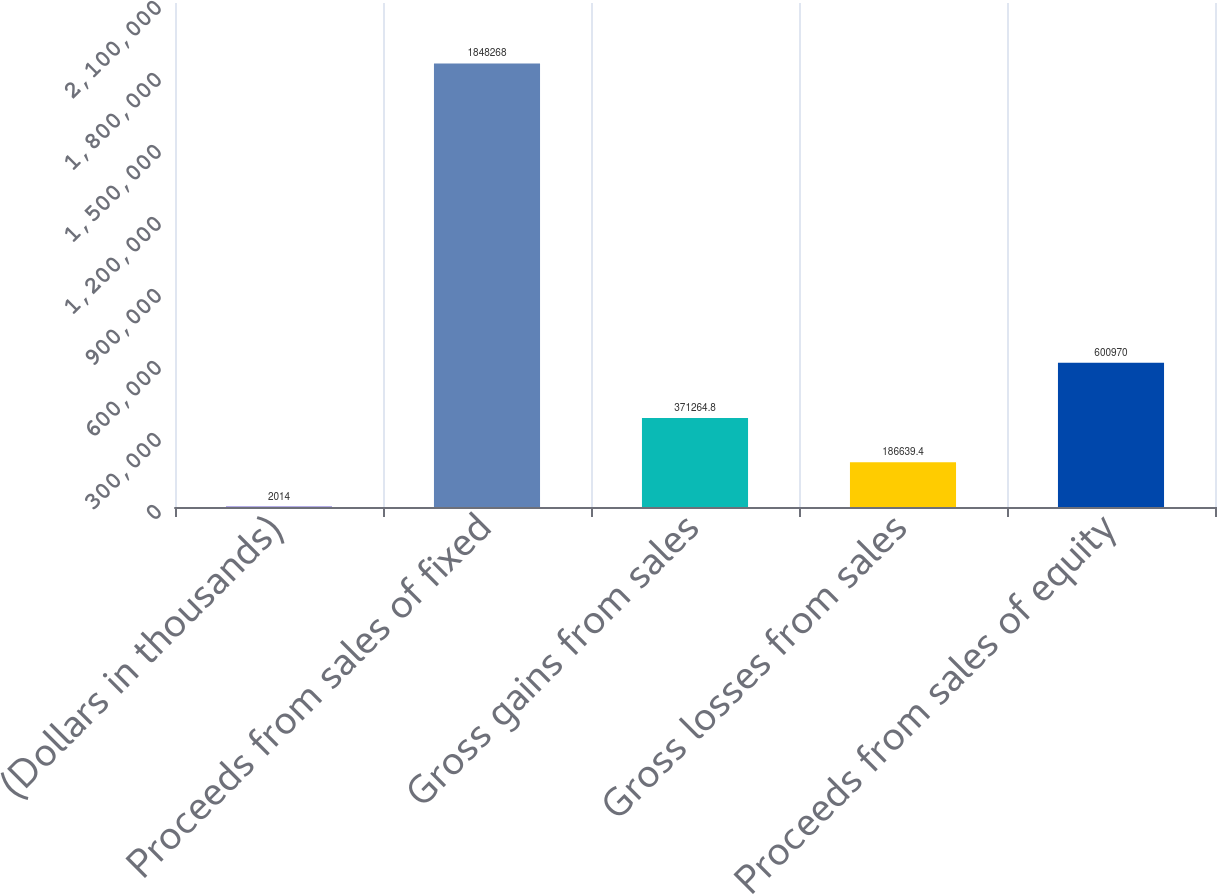Convert chart. <chart><loc_0><loc_0><loc_500><loc_500><bar_chart><fcel>(Dollars in thousands)<fcel>Proceeds from sales of fixed<fcel>Gross gains from sales<fcel>Gross losses from sales<fcel>Proceeds from sales of equity<nl><fcel>2014<fcel>1.84827e+06<fcel>371265<fcel>186639<fcel>600970<nl></chart> 